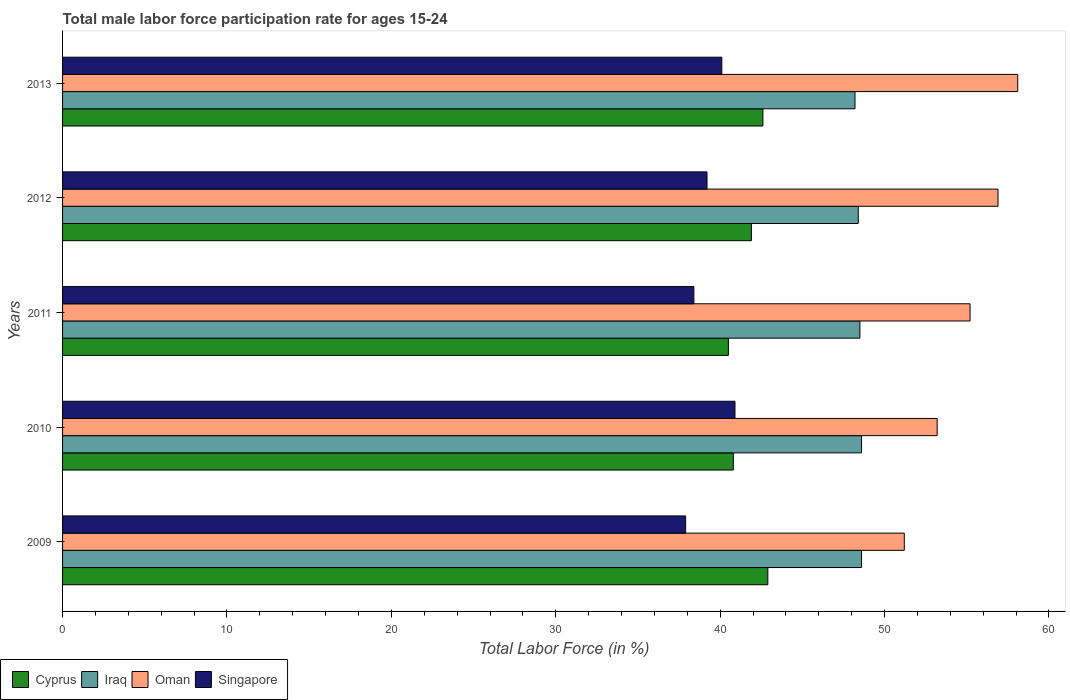How many different coloured bars are there?
Keep it short and to the point. 4. How many bars are there on the 1st tick from the top?
Provide a succinct answer. 4. What is the male labor force participation rate in Singapore in 2013?
Offer a terse response. 40.1. Across all years, what is the maximum male labor force participation rate in Cyprus?
Keep it short and to the point. 42.9. Across all years, what is the minimum male labor force participation rate in Cyprus?
Your response must be concise. 40.5. What is the total male labor force participation rate in Oman in the graph?
Your answer should be compact. 274.6. What is the difference between the male labor force participation rate in Oman in 2012 and that in 2013?
Make the answer very short. -1.2. What is the difference between the male labor force participation rate in Oman in 2011 and the male labor force participation rate in Cyprus in 2013?
Ensure brevity in your answer.  12.6. What is the average male labor force participation rate in Cyprus per year?
Your answer should be very brief. 41.74. In the year 2011, what is the difference between the male labor force participation rate in Singapore and male labor force participation rate in Iraq?
Your response must be concise. -10.1. In how many years, is the male labor force participation rate in Iraq greater than 52 %?
Your response must be concise. 0. What is the ratio of the male labor force participation rate in Singapore in 2011 to that in 2012?
Your answer should be compact. 0.98. What is the difference between the highest and the second highest male labor force participation rate in Cyprus?
Ensure brevity in your answer.  0.3. What is the difference between the highest and the lowest male labor force participation rate in Iraq?
Make the answer very short. 0.4. In how many years, is the male labor force participation rate in Cyprus greater than the average male labor force participation rate in Cyprus taken over all years?
Make the answer very short. 3. Is the sum of the male labor force participation rate in Cyprus in 2010 and 2012 greater than the maximum male labor force participation rate in Iraq across all years?
Offer a very short reply. Yes. Is it the case that in every year, the sum of the male labor force participation rate in Iraq and male labor force participation rate in Oman is greater than the sum of male labor force participation rate in Cyprus and male labor force participation rate in Singapore?
Your answer should be compact. Yes. What does the 1st bar from the top in 2013 represents?
Offer a terse response. Singapore. What does the 1st bar from the bottom in 2009 represents?
Your answer should be compact. Cyprus. Is it the case that in every year, the sum of the male labor force participation rate in Cyprus and male labor force participation rate in Oman is greater than the male labor force participation rate in Singapore?
Ensure brevity in your answer.  Yes. Are all the bars in the graph horizontal?
Offer a very short reply. Yes. How many years are there in the graph?
Offer a terse response. 5. Are the values on the major ticks of X-axis written in scientific E-notation?
Your response must be concise. No. Does the graph contain any zero values?
Your response must be concise. No. How many legend labels are there?
Offer a very short reply. 4. How are the legend labels stacked?
Keep it short and to the point. Horizontal. What is the title of the graph?
Ensure brevity in your answer.  Total male labor force participation rate for ages 15-24. Does "Uzbekistan" appear as one of the legend labels in the graph?
Give a very brief answer. No. What is the label or title of the X-axis?
Offer a very short reply. Total Labor Force (in %). What is the label or title of the Y-axis?
Give a very brief answer. Years. What is the Total Labor Force (in %) in Cyprus in 2009?
Give a very brief answer. 42.9. What is the Total Labor Force (in %) of Iraq in 2009?
Offer a terse response. 48.6. What is the Total Labor Force (in %) of Oman in 2009?
Ensure brevity in your answer.  51.2. What is the Total Labor Force (in %) in Singapore in 2009?
Your response must be concise. 37.9. What is the Total Labor Force (in %) of Cyprus in 2010?
Your answer should be compact. 40.8. What is the Total Labor Force (in %) of Iraq in 2010?
Provide a succinct answer. 48.6. What is the Total Labor Force (in %) of Oman in 2010?
Make the answer very short. 53.2. What is the Total Labor Force (in %) in Singapore in 2010?
Ensure brevity in your answer.  40.9. What is the Total Labor Force (in %) in Cyprus in 2011?
Offer a terse response. 40.5. What is the Total Labor Force (in %) in Iraq in 2011?
Provide a short and direct response. 48.5. What is the Total Labor Force (in %) in Oman in 2011?
Provide a short and direct response. 55.2. What is the Total Labor Force (in %) of Singapore in 2011?
Keep it short and to the point. 38.4. What is the Total Labor Force (in %) in Cyprus in 2012?
Provide a succinct answer. 41.9. What is the Total Labor Force (in %) of Iraq in 2012?
Offer a terse response. 48.4. What is the Total Labor Force (in %) of Oman in 2012?
Provide a succinct answer. 56.9. What is the Total Labor Force (in %) of Singapore in 2012?
Your answer should be very brief. 39.2. What is the Total Labor Force (in %) of Cyprus in 2013?
Provide a short and direct response. 42.6. What is the Total Labor Force (in %) in Iraq in 2013?
Your answer should be compact. 48.2. What is the Total Labor Force (in %) of Oman in 2013?
Offer a very short reply. 58.1. What is the Total Labor Force (in %) of Singapore in 2013?
Provide a succinct answer. 40.1. Across all years, what is the maximum Total Labor Force (in %) of Cyprus?
Offer a terse response. 42.9. Across all years, what is the maximum Total Labor Force (in %) of Iraq?
Provide a succinct answer. 48.6. Across all years, what is the maximum Total Labor Force (in %) in Oman?
Provide a short and direct response. 58.1. Across all years, what is the maximum Total Labor Force (in %) of Singapore?
Provide a short and direct response. 40.9. Across all years, what is the minimum Total Labor Force (in %) of Cyprus?
Your answer should be very brief. 40.5. Across all years, what is the minimum Total Labor Force (in %) of Iraq?
Your response must be concise. 48.2. Across all years, what is the minimum Total Labor Force (in %) of Oman?
Your response must be concise. 51.2. Across all years, what is the minimum Total Labor Force (in %) of Singapore?
Your answer should be compact. 37.9. What is the total Total Labor Force (in %) in Cyprus in the graph?
Offer a very short reply. 208.7. What is the total Total Labor Force (in %) in Iraq in the graph?
Ensure brevity in your answer.  242.3. What is the total Total Labor Force (in %) of Oman in the graph?
Ensure brevity in your answer.  274.6. What is the total Total Labor Force (in %) of Singapore in the graph?
Offer a very short reply. 196.5. What is the difference between the Total Labor Force (in %) of Cyprus in 2009 and that in 2010?
Your answer should be very brief. 2.1. What is the difference between the Total Labor Force (in %) in Singapore in 2009 and that in 2010?
Provide a succinct answer. -3. What is the difference between the Total Labor Force (in %) in Cyprus in 2009 and that in 2011?
Give a very brief answer. 2.4. What is the difference between the Total Labor Force (in %) of Iraq in 2009 and that in 2011?
Provide a succinct answer. 0.1. What is the difference between the Total Labor Force (in %) in Oman in 2009 and that in 2011?
Ensure brevity in your answer.  -4. What is the difference between the Total Labor Force (in %) of Oman in 2009 and that in 2012?
Provide a short and direct response. -5.7. What is the difference between the Total Labor Force (in %) in Singapore in 2009 and that in 2012?
Offer a very short reply. -1.3. What is the difference between the Total Labor Force (in %) of Cyprus in 2009 and that in 2013?
Your answer should be very brief. 0.3. What is the difference between the Total Labor Force (in %) in Oman in 2009 and that in 2013?
Offer a very short reply. -6.9. What is the difference between the Total Labor Force (in %) in Singapore in 2009 and that in 2013?
Make the answer very short. -2.2. What is the difference between the Total Labor Force (in %) in Cyprus in 2010 and that in 2011?
Provide a succinct answer. 0.3. What is the difference between the Total Labor Force (in %) of Cyprus in 2010 and that in 2012?
Your answer should be compact. -1.1. What is the difference between the Total Labor Force (in %) of Iraq in 2010 and that in 2012?
Provide a succinct answer. 0.2. What is the difference between the Total Labor Force (in %) in Oman in 2010 and that in 2012?
Your answer should be very brief. -3.7. What is the difference between the Total Labor Force (in %) of Cyprus in 2010 and that in 2013?
Keep it short and to the point. -1.8. What is the difference between the Total Labor Force (in %) in Iraq in 2010 and that in 2013?
Keep it short and to the point. 0.4. What is the difference between the Total Labor Force (in %) of Singapore in 2010 and that in 2013?
Provide a short and direct response. 0.8. What is the difference between the Total Labor Force (in %) of Singapore in 2011 and that in 2012?
Keep it short and to the point. -0.8. What is the difference between the Total Labor Force (in %) of Oman in 2011 and that in 2013?
Your answer should be compact. -2.9. What is the difference between the Total Labor Force (in %) of Oman in 2012 and that in 2013?
Your response must be concise. -1.2. What is the difference between the Total Labor Force (in %) in Singapore in 2012 and that in 2013?
Offer a very short reply. -0.9. What is the difference between the Total Labor Force (in %) in Cyprus in 2009 and the Total Labor Force (in %) in Singapore in 2010?
Ensure brevity in your answer.  2. What is the difference between the Total Labor Force (in %) in Iraq in 2009 and the Total Labor Force (in %) in Oman in 2010?
Provide a short and direct response. -4.6. What is the difference between the Total Labor Force (in %) in Oman in 2009 and the Total Labor Force (in %) in Singapore in 2010?
Your response must be concise. 10.3. What is the difference between the Total Labor Force (in %) in Iraq in 2009 and the Total Labor Force (in %) in Oman in 2011?
Ensure brevity in your answer.  -6.6. What is the difference between the Total Labor Force (in %) of Cyprus in 2009 and the Total Labor Force (in %) of Iraq in 2012?
Offer a terse response. -5.5. What is the difference between the Total Labor Force (in %) of Iraq in 2009 and the Total Labor Force (in %) of Oman in 2012?
Make the answer very short. -8.3. What is the difference between the Total Labor Force (in %) of Iraq in 2009 and the Total Labor Force (in %) of Singapore in 2012?
Provide a succinct answer. 9.4. What is the difference between the Total Labor Force (in %) in Oman in 2009 and the Total Labor Force (in %) in Singapore in 2012?
Make the answer very short. 12. What is the difference between the Total Labor Force (in %) of Cyprus in 2009 and the Total Labor Force (in %) of Oman in 2013?
Provide a succinct answer. -15.2. What is the difference between the Total Labor Force (in %) of Cyprus in 2009 and the Total Labor Force (in %) of Singapore in 2013?
Your answer should be very brief. 2.8. What is the difference between the Total Labor Force (in %) of Oman in 2009 and the Total Labor Force (in %) of Singapore in 2013?
Your response must be concise. 11.1. What is the difference between the Total Labor Force (in %) in Cyprus in 2010 and the Total Labor Force (in %) in Iraq in 2011?
Ensure brevity in your answer.  -7.7. What is the difference between the Total Labor Force (in %) in Cyprus in 2010 and the Total Labor Force (in %) in Oman in 2011?
Your response must be concise. -14.4. What is the difference between the Total Labor Force (in %) in Cyprus in 2010 and the Total Labor Force (in %) in Singapore in 2011?
Offer a very short reply. 2.4. What is the difference between the Total Labor Force (in %) of Oman in 2010 and the Total Labor Force (in %) of Singapore in 2011?
Offer a very short reply. 14.8. What is the difference between the Total Labor Force (in %) of Cyprus in 2010 and the Total Labor Force (in %) of Iraq in 2012?
Offer a very short reply. -7.6. What is the difference between the Total Labor Force (in %) of Cyprus in 2010 and the Total Labor Force (in %) of Oman in 2012?
Provide a succinct answer. -16.1. What is the difference between the Total Labor Force (in %) of Cyprus in 2010 and the Total Labor Force (in %) of Singapore in 2012?
Your answer should be very brief. 1.6. What is the difference between the Total Labor Force (in %) of Iraq in 2010 and the Total Labor Force (in %) of Oman in 2012?
Offer a terse response. -8.3. What is the difference between the Total Labor Force (in %) of Oman in 2010 and the Total Labor Force (in %) of Singapore in 2012?
Offer a terse response. 14. What is the difference between the Total Labor Force (in %) in Cyprus in 2010 and the Total Labor Force (in %) in Oman in 2013?
Your answer should be compact. -17.3. What is the difference between the Total Labor Force (in %) of Cyprus in 2010 and the Total Labor Force (in %) of Singapore in 2013?
Your answer should be compact. 0.7. What is the difference between the Total Labor Force (in %) of Iraq in 2010 and the Total Labor Force (in %) of Oman in 2013?
Your answer should be very brief. -9.5. What is the difference between the Total Labor Force (in %) of Iraq in 2010 and the Total Labor Force (in %) of Singapore in 2013?
Offer a terse response. 8.5. What is the difference between the Total Labor Force (in %) in Oman in 2010 and the Total Labor Force (in %) in Singapore in 2013?
Provide a succinct answer. 13.1. What is the difference between the Total Labor Force (in %) in Cyprus in 2011 and the Total Labor Force (in %) in Oman in 2012?
Give a very brief answer. -16.4. What is the difference between the Total Labor Force (in %) of Oman in 2011 and the Total Labor Force (in %) of Singapore in 2012?
Keep it short and to the point. 16. What is the difference between the Total Labor Force (in %) in Cyprus in 2011 and the Total Labor Force (in %) in Iraq in 2013?
Offer a terse response. -7.7. What is the difference between the Total Labor Force (in %) in Cyprus in 2011 and the Total Labor Force (in %) in Oman in 2013?
Provide a short and direct response. -17.6. What is the difference between the Total Labor Force (in %) of Iraq in 2011 and the Total Labor Force (in %) of Oman in 2013?
Your answer should be very brief. -9.6. What is the difference between the Total Labor Force (in %) in Iraq in 2011 and the Total Labor Force (in %) in Singapore in 2013?
Provide a short and direct response. 8.4. What is the difference between the Total Labor Force (in %) of Oman in 2011 and the Total Labor Force (in %) of Singapore in 2013?
Give a very brief answer. 15.1. What is the difference between the Total Labor Force (in %) in Cyprus in 2012 and the Total Labor Force (in %) in Oman in 2013?
Keep it short and to the point. -16.2. What is the difference between the Total Labor Force (in %) of Cyprus in 2012 and the Total Labor Force (in %) of Singapore in 2013?
Your answer should be compact. 1.8. What is the difference between the Total Labor Force (in %) of Iraq in 2012 and the Total Labor Force (in %) of Singapore in 2013?
Your response must be concise. 8.3. What is the difference between the Total Labor Force (in %) in Oman in 2012 and the Total Labor Force (in %) in Singapore in 2013?
Make the answer very short. 16.8. What is the average Total Labor Force (in %) in Cyprus per year?
Keep it short and to the point. 41.74. What is the average Total Labor Force (in %) of Iraq per year?
Give a very brief answer. 48.46. What is the average Total Labor Force (in %) of Oman per year?
Ensure brevity in your answer.  54.92. What is the average Total Labor Force (in %) of Singapore per year?
Your response must be concise. 39.3. In the year 2009, what is the difference between the Total Labor Force (in %) in Cyprus and Total Labor Force (in %) in Singapore?
Keep it short and to the point. 5. In the year 2009, what is the difference between the Total Labor Force (in %) in Oman and Total Labor Force (in %) in Singapore?
Your answer should be compact. 13.3. In the year 2010, what is the difference between the Total Labor Force (in %) in Iraq and Total Labor Force (in %) in Oman?
Keep it short and to the point. -4.6. In the year 2010, what is the difference between the Total Labor Force (in %) in Oman and Total Labor Force (in %) in Singapore?
Provide a succinct answer. 12.3. In the year 2011, what is the difference between the Total Labor Force (in %) of Cyprus and Total Labor Force (in %) of Oman?
Offer a very short reply. -14.7. In the year 2011, what is the difference between the Total Labor Force (in %) of Cyprus and Total Labor Force (in %) of Singapore?
Your answer should be very brief. 2.1. In the year 2011, what is the difference between the Total Labor Force (in %) of Iraq and Total Labor Force (in %) of Oman?
Provide a succinct answer. -6.7. In the year 2011, what is the difference between the Total Labor Force (in %) in Oman and Total Labor Force (in %) in Singapore?
Ensure brevity in your answer.  16.8. In the year 2012, what is the difference between the Total Labor Force (in %) of Cyprus and Total Labor Force (in %) of Iraq?
Offer a very short reply. -6.5. In the year 2012, what is the difference between the Total Labor Force (in %) of Cyprus and Total Labor Force (in %) of Singapore?
Your response must be concise. 2.7. In the year 2012, what is the difference between the Total Labor Force (in %) in Oman and Total Labor Force (in %) in Singapore?
Keep it short and to the point. 17.7. In the year 2013, what is the difference between the Total Labor Force (in %) in Cyprus and Total Labor Force (in %) in Iraq?
Your answer should be compact. -5.6. In the year 2013, what is the difference between the Total Labor Force (in %) of Cyprus and Total Labor Force (in %) of Oman?
Offer a terse response. -15.5. In the year 2013, what is the difference between the Total Labor Force (in %) of Cyprus and Total Labor Force (in %) of Singapore?
Ensure brevity in your answer.  2.5. What is the ratio of the Total Labor Force (in %) of Cyprus in 2009 to that in 2010?
Ensure brevity in your answer.  1.05. What is the ratio of the Total Labor Force (in %) of Oman in 2009 to that in 2010?
Ensure brevity in your answer.  0.96. What is the ratio of the Total Labor Force (in %) in Singapore in 2009 to that in 2010?
Make the answer very short. 0.93. What is the ratio of the Total Labor Force (in %) of Cyprus in 2009 to that in 2011?
Your response must be concise. 1.06. What is the ratio of the Total Labor Force (in %) in Iraq in 2009 to that in 2011?
Your response must be concise. 1. What is the ratio of the Total Labor Force (in %) of Oman in 2009 to that in 2011?
Your answer should be compact. 0.93. What is the ratio of the Total Labor Force (in %) of Cyprus in 2009 to that in 2012?
Your answer should be compact. 1.02. What is the ratio of the Total Labor Force (in %) in Oman in 2009 to that in 2012?
Offer a terse response. 0.9. What is the ratio of the Total Labor Force (in %) in Singapore in 2009 to that in 2012?
Provide a succinct answer. 0.97. What is the ratio of the Total Labor Force (in %) in Cyprus in 2009 to that in 2013?
Ensure brevity in your answer.  1.01. What is the ratio of the Total Labor Force (in %) in Iraq in 2009 to that in 2013?
Make the answer very short. 1.01. What is the ratio of the Total Labor Force (in %) in Oman in 2009 to that in 2013?
Provide a succinct answer. 0.88. What is the ratio of the Total Labor Force (in %) in Singapore in 2009 to that in 2013?
Make the answer very short. 0.95. What is the ratio of the Total Labor Force (in %) of Cyprus in 2010 to that in 2011?
Ensure brevity in your answer.  1.01. What is the ratio of the Total Labor Force (in %) of Oman in 2010 to that in 2011?
Provide a succinct answer. 0.96. What is the ratio of the Total Labor Force (in %) of Singapore in 2010 to that in 2011?
Keep it short and to the point. 1.07. What is the ratio of the Total Labor Force (in %) of Cyprus in 2010 to that in 2012?
Make the answer very short. 0.97. What is the ratio of the Total Labor Force (in %) in Iraq in 2010 to that in 2012?
Keep it short and to the point. 1. What is the ratio of the Total Labor Force (in %) of Oman in 2010 to that in 2012?
Give a very brief answer. 0.94. What is the ratio of the Total Labor Force (in %) in Singapore in 2010 to that in 2012?
Keep it short and to the point. 1.04. What is the ratio of the Total Labor Force (in %) of Cyprus in 2010 to that in 2013?
Provide a short and direct response. 0.96. What is the ratio of the Total Labor Force (in %) in Iraq in 2010 to that in 2013?
Ensure brevity in your answer.  1.01. What is the ratio of the Total Labor Force (in %) in Oman in 2010 to that in 2013?
Keep it short and to the point. 0.92. What is the ratio of the Total Labor Force (in %) of Singapore in 2010 to that in 2013?
Offer a terse response. 1.02. What is the ratio of the Total Labor Force (in %) of Cyprus in 2011 to that in 2012?
Make the answer very short. 0.97. What is the ratio of the Total Labor Force (in %) of Iraq in 2011 to that in 2012?
Your answer should be very brief. 1. What is the ratio of the Total Labor Force (in %) of Oman in 2011 to that in 2012?
Provide a succinct answer. 0.97. What is the ratio of the Total Labor Force (in %) in Singapore in 2011 to that in 2012?
Offer a very short reply. 0.98. What is the ratio of the Total Labor Force (in %) in Cyprus in 2011 to that in 2013?
Keep it short and to the point. 0.95. What is the ratio of the Total Labor Force (in %) of Iraq in 2011 to that in 2013?
Keep it short and to the point. 1.01. What is the ratio of the Total Labor Force (in %) of Oman in 2011 to that in 2013?
Your response must be concise. 0.95. What is the ratio of the Total Labor Force (in %) of Singapore in 2011 to that in 2013?
Ensure brevity in your answer.  0.96. What is the ratio of the Total Labor Force (in %) in Cyprus in 2012 to that in 2013?
Your answer should be compact. 0.98. What is the ratio of the Total Labor Force (in %) of Oman in 2012 to that in 2013?
Provide a short and direct response. 0.98. What is the ratio of the Total Labor Force (in %) of Singapore in 2012 to that in 2013?
Ensure brevity in your answer.  0.98. What is the difference between the highest and the second highest Total Labor Force (in %) of Cyprus?
Keep it short and to the point. 0.3. What is the difference between the highest and the second highest Total Labor Force (in %) in Iraq?
Offer a terse response. 0. What is the difference between the highest and the second highest Total Labor Force (in %) of Oman?
Give a very brief answer. 1.2. What is the difference between the highest and the lowest Total Labor Force (in %) of Oman?
Provide a short and direct response. 6.9. What is the difference between the highest and the lowest Total Labor Force (in %) of Singapore?
Ensure brevity in your answer.  3. 